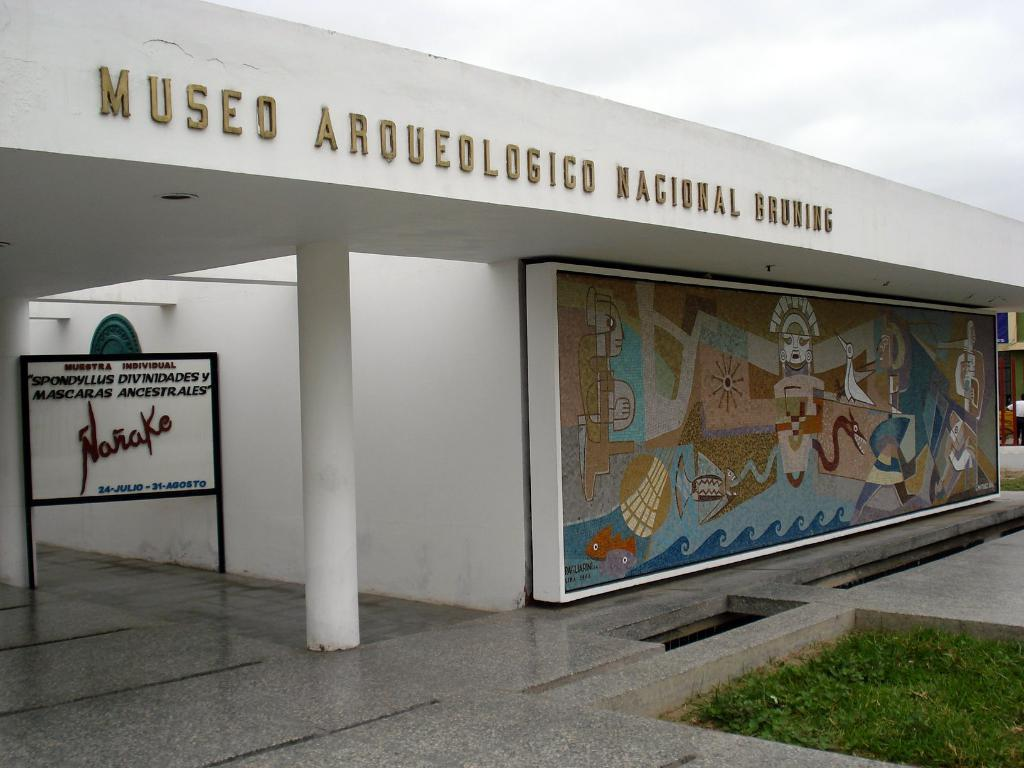What type of structure is in the image? There is a building in the image. What is the color of the building? The building is white in color. What is in front of the building? There is a board in front of the building. What can be seen below the building? There is a floor visible in the image, and grass is present on the floor. What is located in the middle of the image? There is a pillar in the middle of the image. What type of hose is connected to the machine in the image? There is no hose or machine present in the image. How many bees can be seen flying around the building in the image? There are no bees visible in the image. 